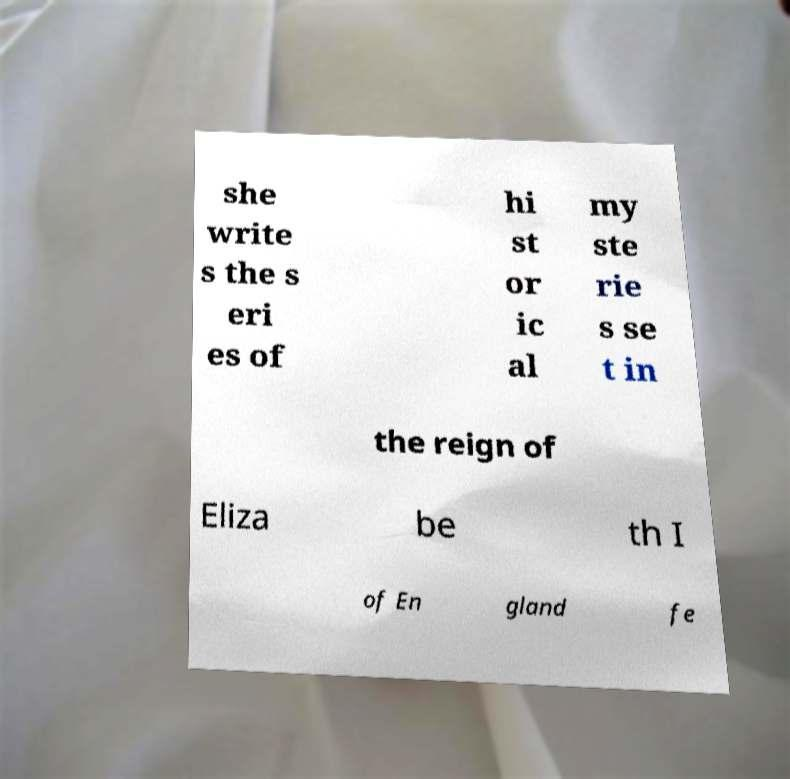Please identify and transcribe the text found in this image. she write s the s eri es of hi st or ic al my ste rie s se t in the reign of Eliza be th I of En gland fe 